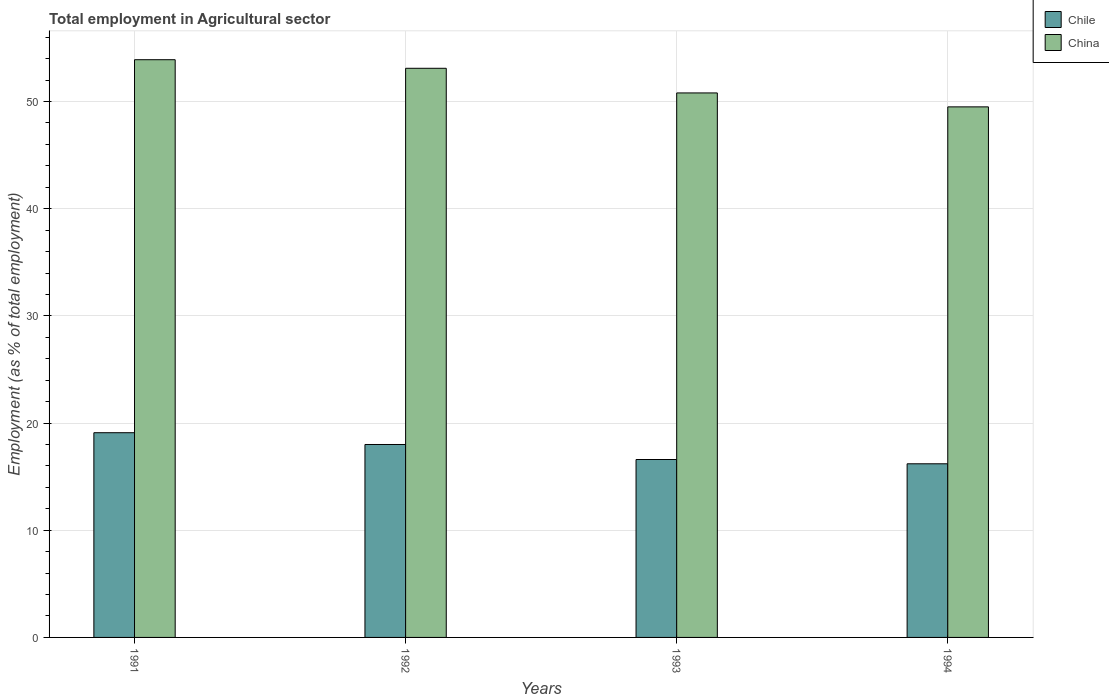How many different coloured bars are there?
Keep it short and to the point. 2. How many groups of bars are there?
Ensure brevity in your answer.  4. How many bars are there on the 2nd tick from the left?
Give a very brief answer. 2. What is the label of the 1st group of bars from the left?
Make the answer very short. 1991. What is the employment in agricultural sector in Chile in 1994?
Your answer should be very brief. 16.2. Across all years, what is the maximum employment in agricultural sector in China?
Provide a short and direct response. 53.9. Across all years, what is the minimum employment in agricultural sector in China?
Your answer should be compact. 49.5. In which year was the employment in agricultural sector in Chile maximum?
Offer a very short reply. 1991. What is the total employment in agricultural sector in Chile in the graph?
Ensure brevity in your answer.  69.9. What is the difference between the employment in agricultural sector in China in 1992 and that in 1993?
Give a very brief answer. 2.3. What is the difference between the employment in agricultural sector in China in 1993 and the employment in agricultural sector in Chile in 1991?
Make the answer very short. 31.7. What is the average employment in agricultural sector in Chile per year?
Your response must be concise. 17.48. In the year 1991, what is the difference between the employment in agricultural sector in Chile and employment in agricultural sector in China?
Your answer should be compact. -34.8. What is the ratio of the employment in agricultural sector in Chile in 1993 to that in 1994?
Make the answer very short. 1.02. Is the employment in agricultural sector in China in 1993 less than that in 1994?
Provide a succinct answer. No. What is the difference between the highest and the second highest employment in agricultural sector in Chile?
Keep it short and to the point. 1.1. What is the difference between the highest and the lowest employment in agricultural sector in Chile?
Provide a succinct answer. 2.9. In how many years, is the employment in agricultural sector in China greater than the average employment in agricultural sector in China taken over all years?
Make the answer very short. 2. How many bars are there?
Make the answer very short. 8. Are all the bars in the graph horizontal?
Offer a very short reply. No. How are the legend labels stacked?
Make the answer very short. Vertical. What is the title of the graph?
Make the answer very short. Total employment in Agricultural sector. Does "Chad" appear as one of the legend labels in the graph?
Your answer should be very brief. No. What is the label or title of the Y-axis?
Keep it short and to the point. Employment (as % of total employment). What is the Employment (as % of total employment) in Chile in 1991?
Provide a succinct answer. 19.1. What is the Employment (as % of total employment) in China in 1991?
Make the answer very short. 53.9. What is the Employment (as % of total employment) of China in 1992?
Offer a very short reply. 53.1. What is the Employment (as % of total employment) in Chile in 1993?
Keep it short and to the point. 16.6. What is the Employment (as % of total employment) of China in 1993?
Ensure brevity in your answer.  50.8. What is the Employment (as % of total employment) in Chile in 1994?
Offer a very short reply. 16.2. What is the Employment (as % of total employment) of China in 1994?
Ensure brevity in your answer.  49.5. Across all years, what is the maximum Employment (as % of total employment) in Chile?
Provide a succinct answer. 19.1. Across all years, what is the maximum Employment (as % of total employment) of China?
Provide a short and direct response. 53.9. Across all years, what is the minimum Employment (as % of total employment) in Chile?
Make the answer very short. 16.2. Across all years, what is the minimum Employment (as % of total employment) in China?
Provide a succinct answer. 49.5. What is the total Employment (as % of total employment) of Chile in the graph?
Your answer should be very brief. 69.9. What is the total Employment (as % of total employment) of China in the graph?
Ensure brevity in your answer.  207.3. What is the difference between the Employment (as % of total employment) in China in 1991 and that in 1992?
Your response must be concise. 0.8. What is the difference between the Employment (as % of total employment) in Chile in 1991 and that in 1994?
Keep it short and to the point. 2.9. What is the difference between the Employment (as % of total employment) of China in 1991 and that in 1994?
Offer a very short reply. 4.4. What is the difference between the Employment (as % of total employment) of Chile in 1992 and that in 1993?
Make the answer very short. 1.4. What is the difference between the Employment (as % of total employment) of Chile in 1992 and that in 1994?
Ensure brevity in your answer.  1.8. What is the difference between the Employment (as % of total employment) in Chile in 1991 and the Employment (as % of total employment) in China in 1992?
Offer a terse response. -34. What is the difference between the Employment (as % of total employment) of Chile in 1991 and the Employment (as % of total employment) of China in 1993?
Offer a terse response. -31.7. What is the difference between the Employment (as % of total employment) in Chile in 1991 and the Employment (as % of total employment) in China in 1994?
Your answer should be compact. -30.4. What is the difference between the Employment (as % of total employment) in Chile in 1992 and the Employment (as % of total employment) in China in 1993?
Offer a terse response. -32.8. What is the difference between the Employment (as % of total employment) of Chile in 1992 and the Employment (as % of total employment) of China in 1994?
Your answer should be very brief. -31.5. What is the difference between the Employment (as % of total employment) of Chile in 1993 and the Employment (as % of total employment) of China in 1994?
Keep it short and to the point. -32.9. What is the average Employment (as % of total employment) in Chile per year?
Make the answer very short. 17.48. What is the average Employment (as % of total employment) of China per year?
Provide a succinct answer. 51.83. In the year 1991, what is the difference between the Employment (as % of total employment) in Chile and Employment (as % of total employment) in China?
Keep it short and to the point. -34.8. In the year 1992, what is the difference between the Employment (as % of total employment) in Chile and Employment (as % of total employment) in China?
Your answer should be compact. -35.1. In the year 1993, what is the difference between the Employment (as % of total employment) in Chile and Employment (as % of total employment) in China?
Give a very brief answer. -34.2. In the year 1994, what is the difference between the Employment (as % of total employment) in Chile and Employment (as % of total employment) in China?
Offer a very short reply. -33.3. What is the ratio of the Employment (as % of total employment) of Chile in 1991 to that in 1992?
Give a very brief answer. 1.06. What is the ratio of the Employment (as % of total employment) in China in 1991 to that in 1992?
Provide a succinct answer. 1.02. What is the ratio of the Employment (as % of total employment) of Chile in 1991 to that in 1993?
Give a very brief answer. 1.15. What is the ratio of the Employment (as % of total employment) of China in 1991 to that in 1993?
Your answer should be compact. 1.06. What is the ratio of the Employment (as % of total employment) of Chile in 1991 to that in 1994?
Offer a very short reply. 1.18. What is the ratio of the Employment (as % of total employment) in China in 1991 to that in 1994?
Offer a very short reply. 1.09. What is the ratio of the Employment (as % of total employment) of Chile in 1992 to that in 1993?
Provide a succinct answer. 1.08. What is the ratio of the Employment (as % of total employment) of China in 1992 to that in 1993?
Offer a very short reply. 1.05. What is the ratio of the Employment (as % of total employment) of Chile in 1992 to that in 1994?
Your response must be concise. 1.11. What is the ratio of the Employment (as % of total employment) in China in 1992 to that in 1994?
Your answer should be very brief. 1.07. What is the ratio of the Employment (as % of total employment) in Chile in 1993 to that in 1994?
Give a very brief answer. 1.02. What is the ratio of the Employment (as % of total employment) of China in 1993 to that in 1994?
Your answer should be compact. 1.03. What is the difference between the highest and the second highest Employment (as % of total employment) of Chile?
Provide a short and direct response. 1.1. 